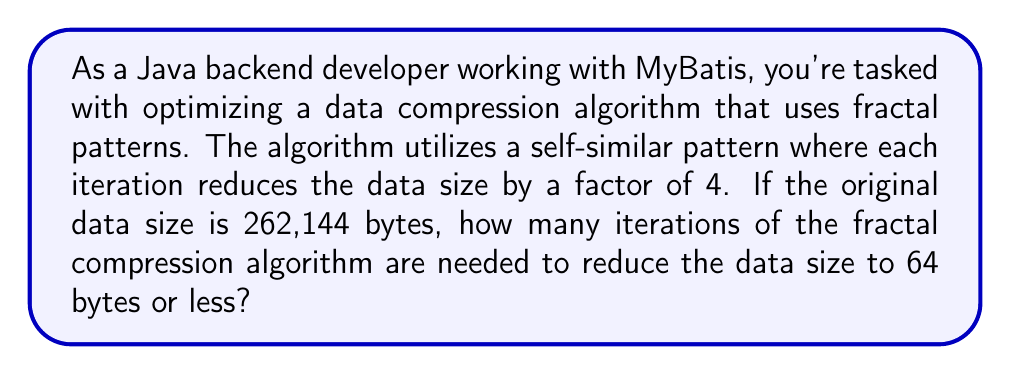Teach me how to tackle this problem. Let's approach this step-by-step:

1) The initial data size is 262,144 bytes.
2) Each iteration reduces the data size by a factor of 4.
3) We need to find how many times we need to divide by 4 to get to 64 bytes or less.

Mathematically, we can express this as:

$$ \frac{262,144}{4^n} \leq 64 $$

Where $n$ is the number of iterations we're solving for.

Let's solve this inequality:

$$ 262,144 \leq 64 \cdot 4^n $$
$$ 4,096 \leq 4^n $$

Now, we can take the logarithm (base 4) of both sides:

$$ \log_4(4,096) \leq n $$

$$ 6 \leq n $$

The logarithm of 4,096 (base 4) is exactly 6 because $4^6 = 4,096$.

Therefore, we need at least 6 iterations to reduce the data size to 64 bytes or less.

We can verify:
$$ 262,144 / 4^6 = 262,144 / 4,096 = 64 $$

Thus, 6 iterations will reduce the data to exactly 64 bytes.
Answer: 6 iterations 